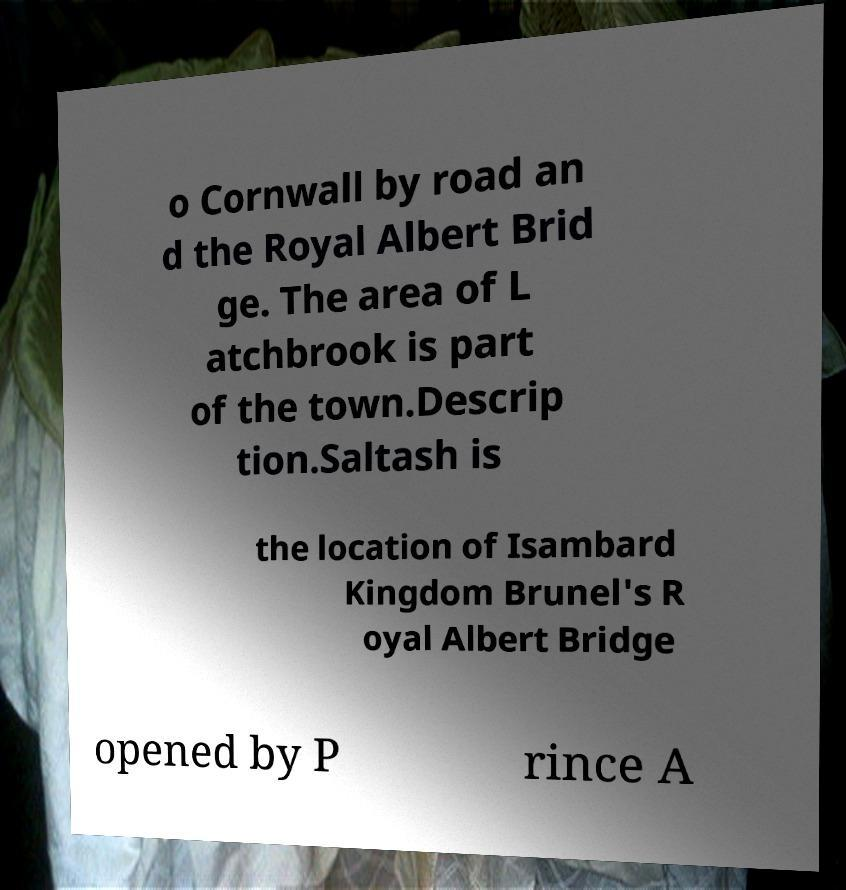For documentation purposes, I need the text within this image transcribed. Could you provide that? o Cornwall by road an d the Royal Albert Brid ge. The area of L atchbrook is part of the town.Descrip tion.Saltash is the location of Isambard Kingdom Brunel's R oyal Albert Bridge opened by P rince A 